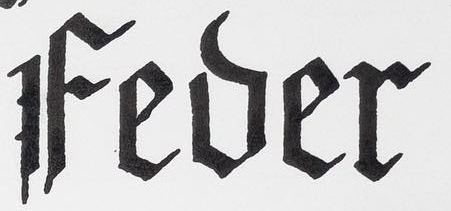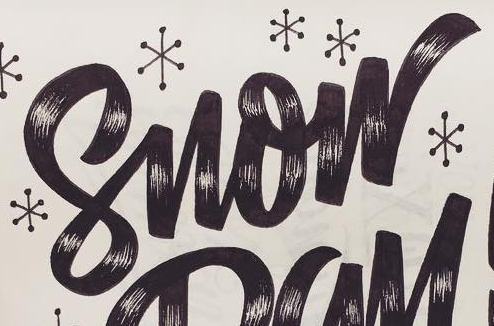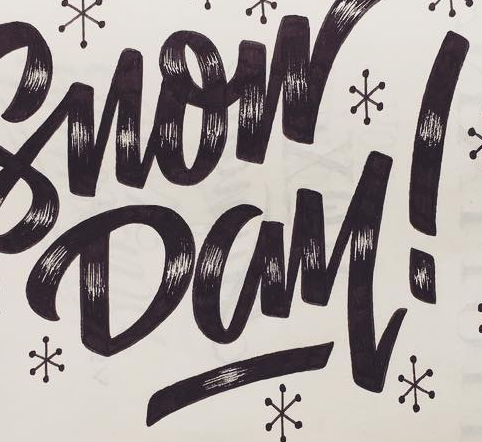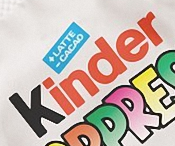What text appears in these images from left to right, separated by a semicolon? Fever; Snow; Day!; Kinder 